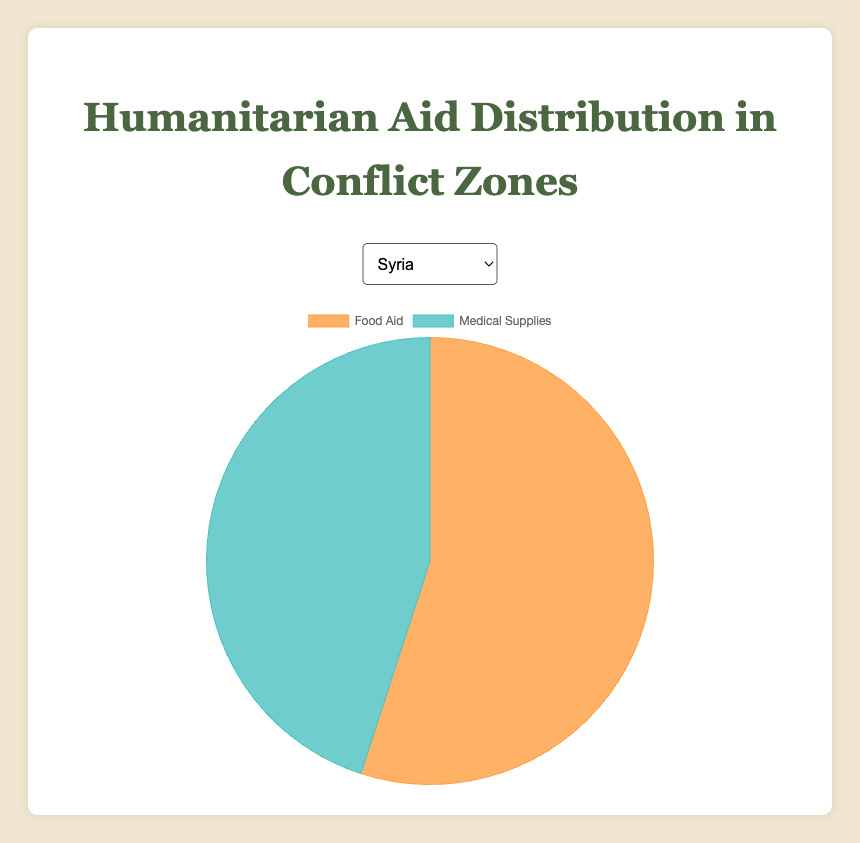Which region receives more food aid than medical supplies? Looking at the pie charts provided for each region, we can compare the food aid and medical supplies proportions. The regions where the proportion of food aid is higher than medical supplies are Syria (55% vs. 45%), Yemen (70% vs. 30%), South Sudan (60% vs. 40%), and Afghanistan (50% vs. 50%). Therefore, the regions receiving more food aid than medical supplies are Syria, Yemen, and South Sudan.
Answer: Syria, Yemen, South Sudan Which region has an equal distribution of food aid and medical supplies? From the pie charts, Afghanistan is the only region where the distribution of food aid and medical supplies is equal, at 50% for each.
Answer: Afghanistan What is the combined percentage of food aid and medical supplies in Yemen? In Yemen, food aid accounts for 70%, and medical supplies make up 30%. Combining these gives us 70% + 30% = 100%.
Answer: 100% Which region has the highest percentage of medical supplies compared to food aid? By examining the pie charts, the region with the highest percentage of medical supplies compared to food aid is Ukraine, with medical supplies at 60% and food aid at 40%.
Answer: Ukraine Which region has a more balanced distribution of aid, Syria or South Sudan? In Syria, the distribution is 55% food aid and 45% medical supplies, whereas in South Sudan, it is 60% food aid and 40% medical supplies. Syria has a more balanced distribution because the percentages are closer to each other.
Answer: Syria What is the difference in the percentage of food aid and medical supplies in Ukraine? In Ukraine, the percentage of food aid is 40%, and medical supplies is 60%. The difference is 60% - 40% = 20%.
Answer: 20% Is there any region where food aid is less than medical supplies? From the provided data, Ukraine is the only region where food aid (40%) is less than medical supplies (60%).
Answer: Ukraine What is the average percentage of food aid across Syria, Yemen, and South Sudan? To find the average, add the food aid percentages of Syria (55%), Yemen (70%), and South Sudan (60%), then divide by the number of regions, which is 3. (55 + 70 + 60) / 3 = 185 / 3 ≈ 61.67%.
Answer: ~61.67% Comparing Syria and Yemen, which region receives higher total humanitarian aid distribution? Both lines of humanitarian aid must sum up to 100%; thus, the total humanitarian aid distribution for each region is 100%. Therefore, there is no region with a higher total humanitarian aid distribution.
Answer: Equal In which region is the need for medical supplies greater, measured by the proportion of total aid? The region with the highest proportion of medical supplies is Ukraine, where medical supplies account for 60% of the total aid.
Answer: Ukraine 